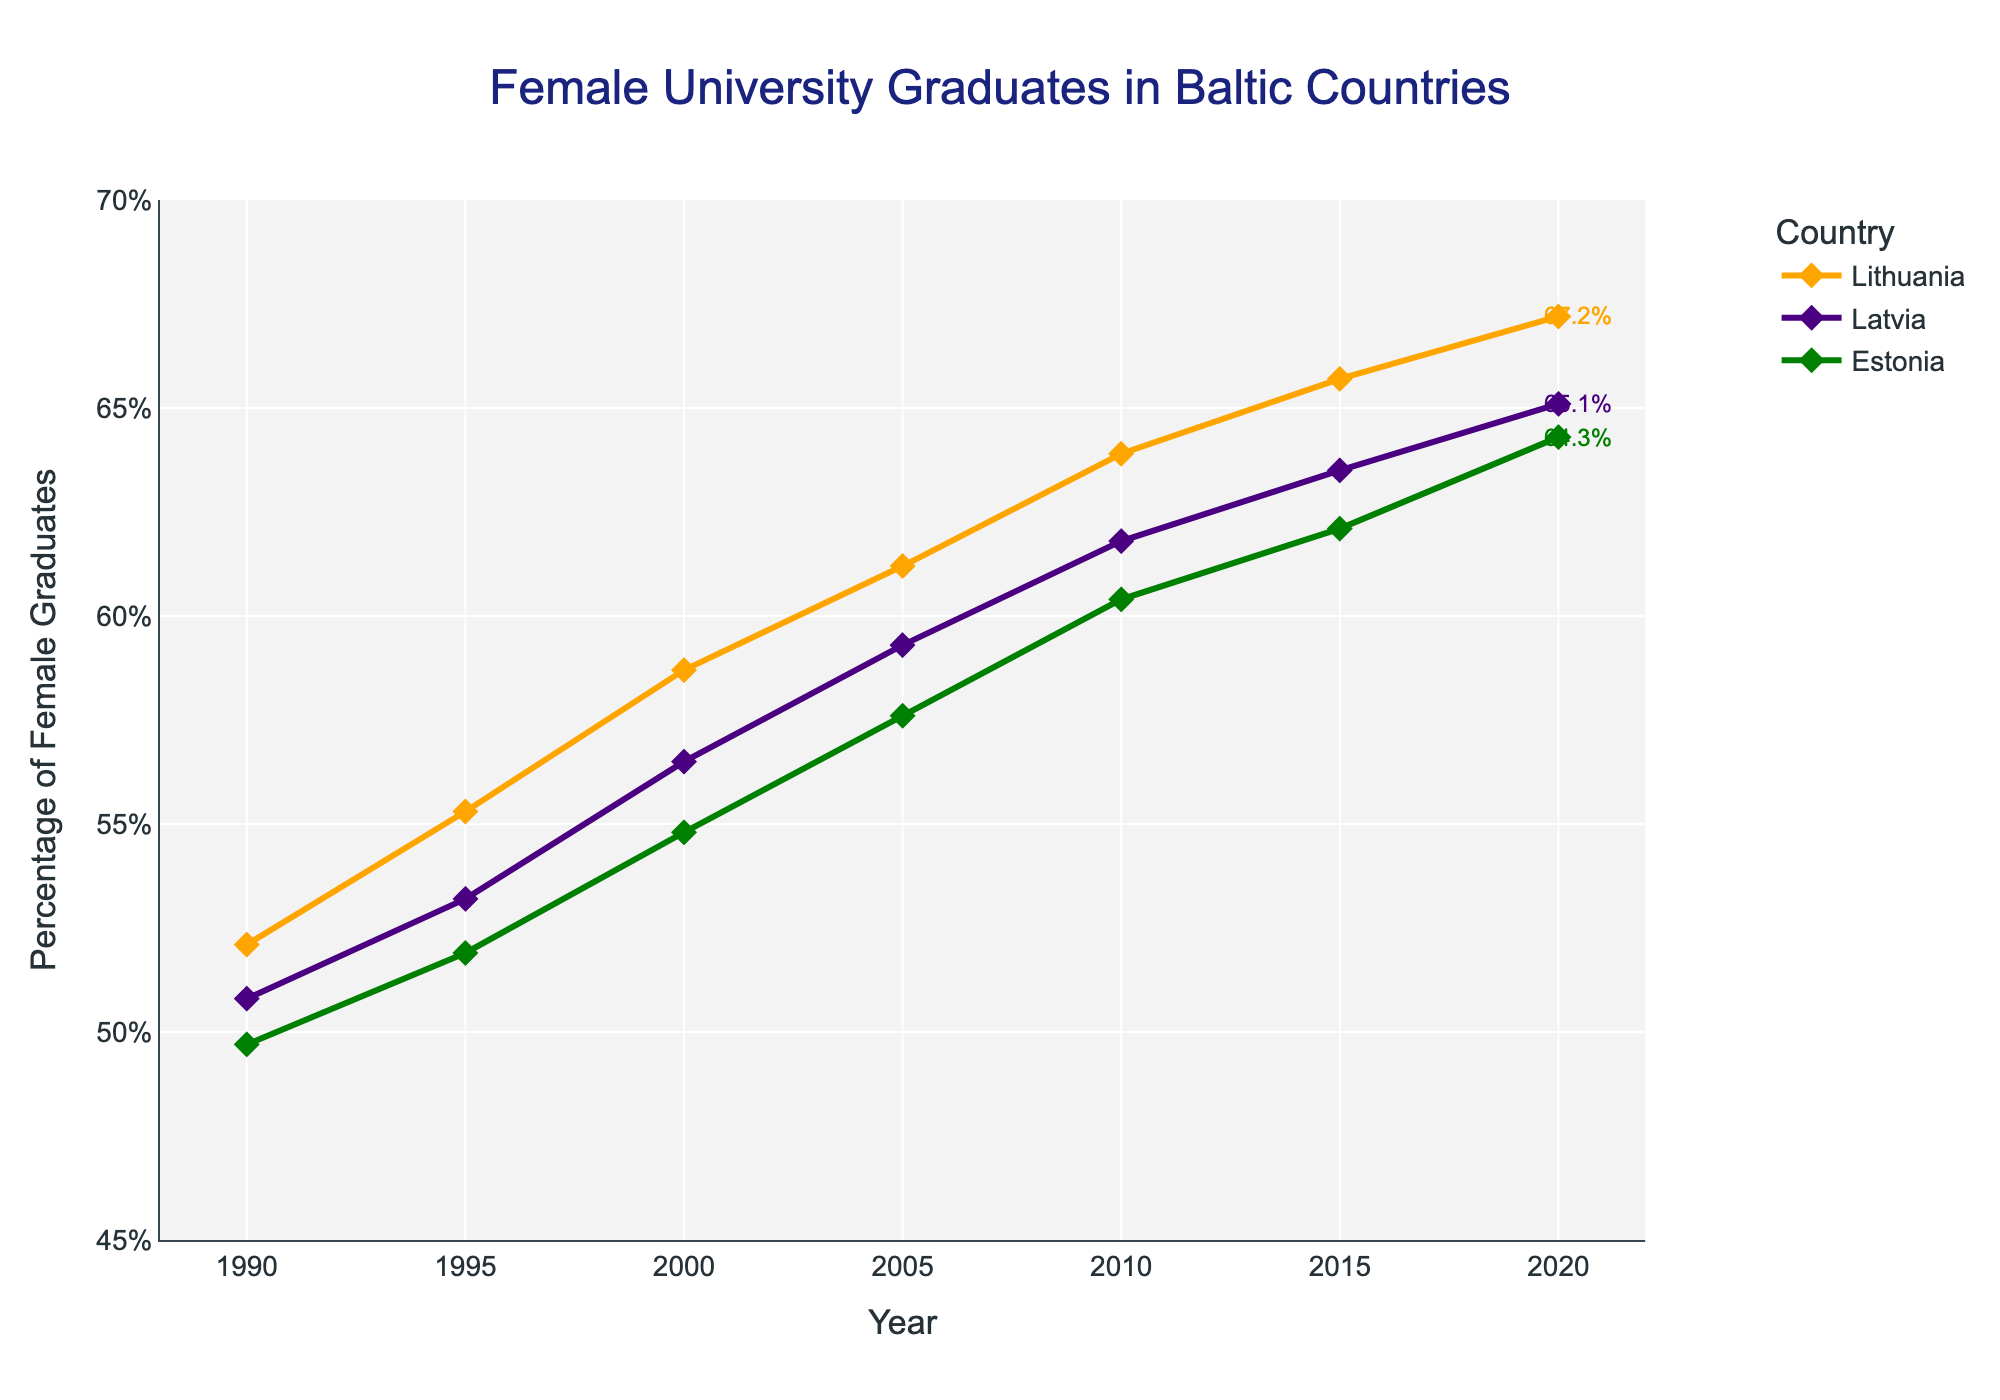Which country had the highest percentage of female university graduates in 2020? To find the answer, look at the endpoints of the lines in the chart for the year 2020. The highest point belongs to Lithuania.
Answer: Lithuania How did the percentage of female graduates in Estonia change from 1990 to 2005? First, note the percentage in 1990 and 2005 for Estonia from the chart. Then, compute the difference: 57.6% (2005) - 49.7% (1990).
Answer: 7.9% Which country shows the least growth in the percentage of female graduates from 1990 to 2020? Observe the starting and ending points of all the lines. Compute the difference for each country and find the smallest value. Estonia's growth is from 49.7% to 64.3%, Latvia's from 50.8% to 65.1%, and Lithuania's from 52.1% to 67.2%. Estonia has the smallest increase.
Answer: Estonia In 2010, what is the difference in percentage points between Lithuania and Latvia? Look at the data points for Lithuania and Latvia in 2010 and subtract the percentage of Latvia from Lithuania: 63.9% - 61.8%.
Answer: 2.1% Which year had the closest percentage of female graduates between all three countries? Check the lines in the chart to see in which year the values are most convergent. In 1990, the percentages are very close: Lithuania (52.1%), Latvia (50.8%), Estonia (49.7%).
Answer: 1990 What is the average percentage of female graduates in Lithuania from 1990 to 2020? Add the percentages for Lithuania from 1990 to 2020 and divide by the number of data points: (52.1+55.3+58.7+61.2+63.9+65.7+67.2)/7.
Answer: 60.58% Which country's trend line shows the steepest upward slope? Compare the slopes of the lines visually. Lithuania's line appears to increase most steeply over the years.
Answer: Lithuania What are the annotations next to the lines for each country representing? Annotations show the percentage values at the endpoint (2020) for Lithuania, Latvia, and Estonia.
Answer: Percentage values at 2020 